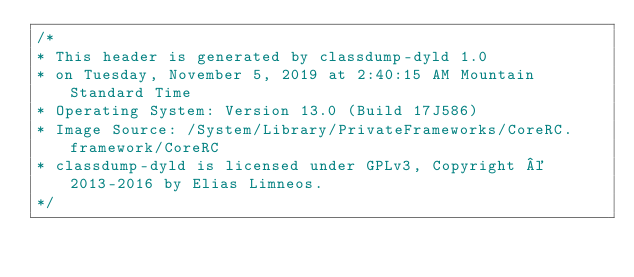<code> <loc_0><loc_0><loc_500><loc_500><_C_>/*
* This header is generated by classdump-dyld 1.0
* on Tuesday, November 5, 2019 at 2:40:15 AM Mountain Standard Time
* Operating System: Version 13.0 (Build 17J586)
* Image Source: /System/Library/PrivateFrameworks/CoreRC.framework/CoreRC
* classdump-dyld is licensed under GPLv3, Copyright © 2013-2016 by Elias Limneos.
*/

</code> 